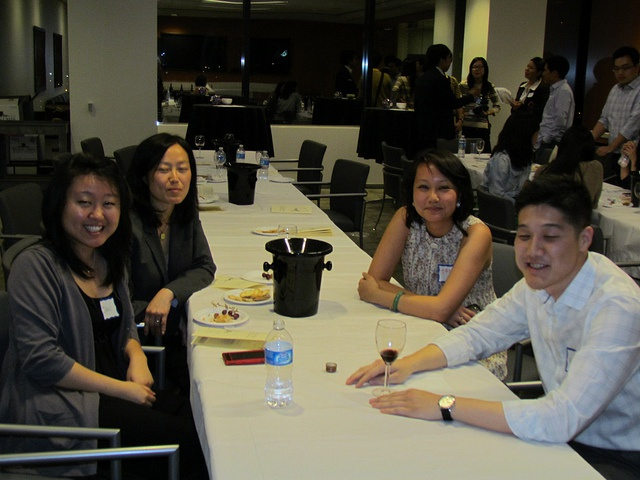Describe the objects in this image and their specific colors. I can see people in black, darkgray, gray, and tan tones, dining table in black and tan tones, people in black, gray, and maroon tones, dining table in black, tan, and gray tones, and people in black, gray, and maroon tones in this image. 